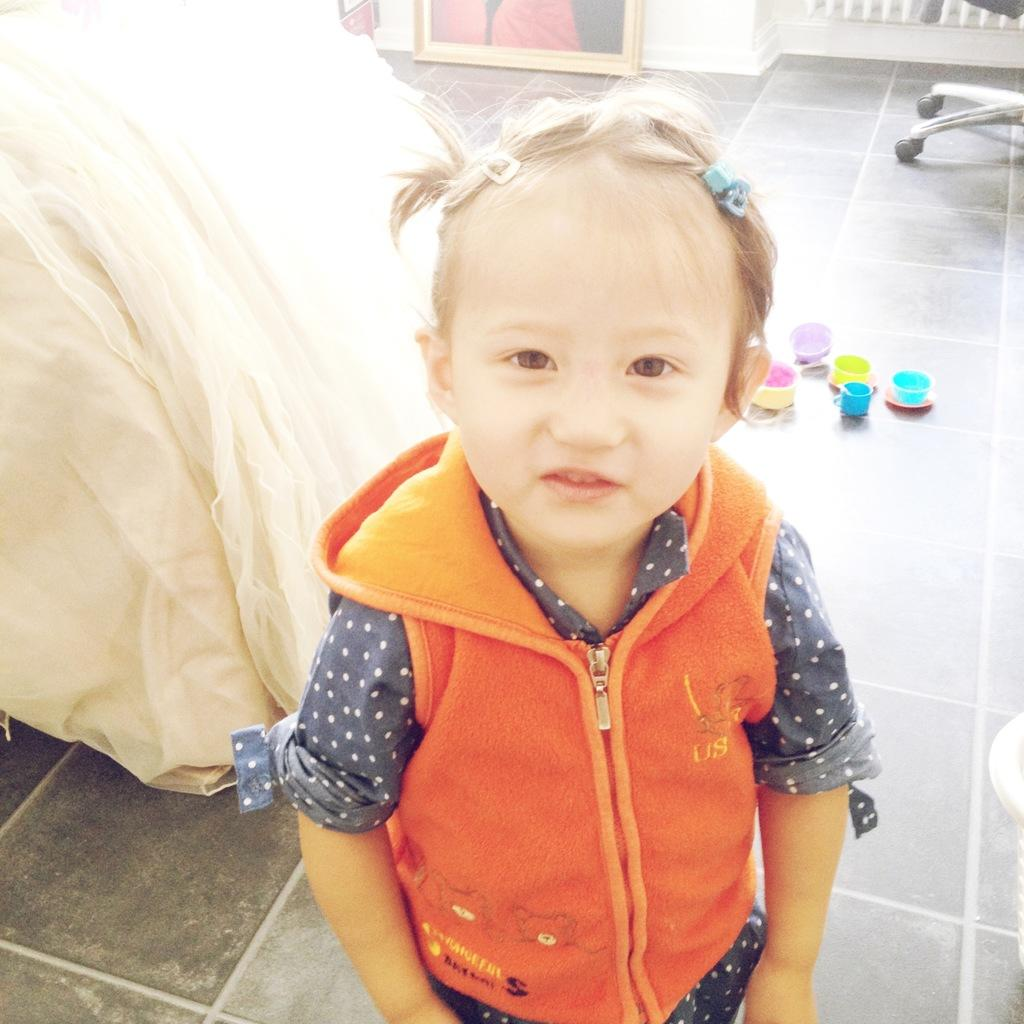Who is the main subject in the image? There is a girl in the image. What is the girl wearing? The girl is wearing an orange jacket. What else can be seen in the image besides the girl? There is a cloth, plastic cups on the ground, a wall, a frame, and a chair in the image. Where is the kitty sitting on the cloth in the image? There is no kitty present in the image. Can you see any cobwebs in the frame in the background of the image? There is no mention of cobwebs in the image, and the frame is not described in enough detail to determine if cobwebs are present. 